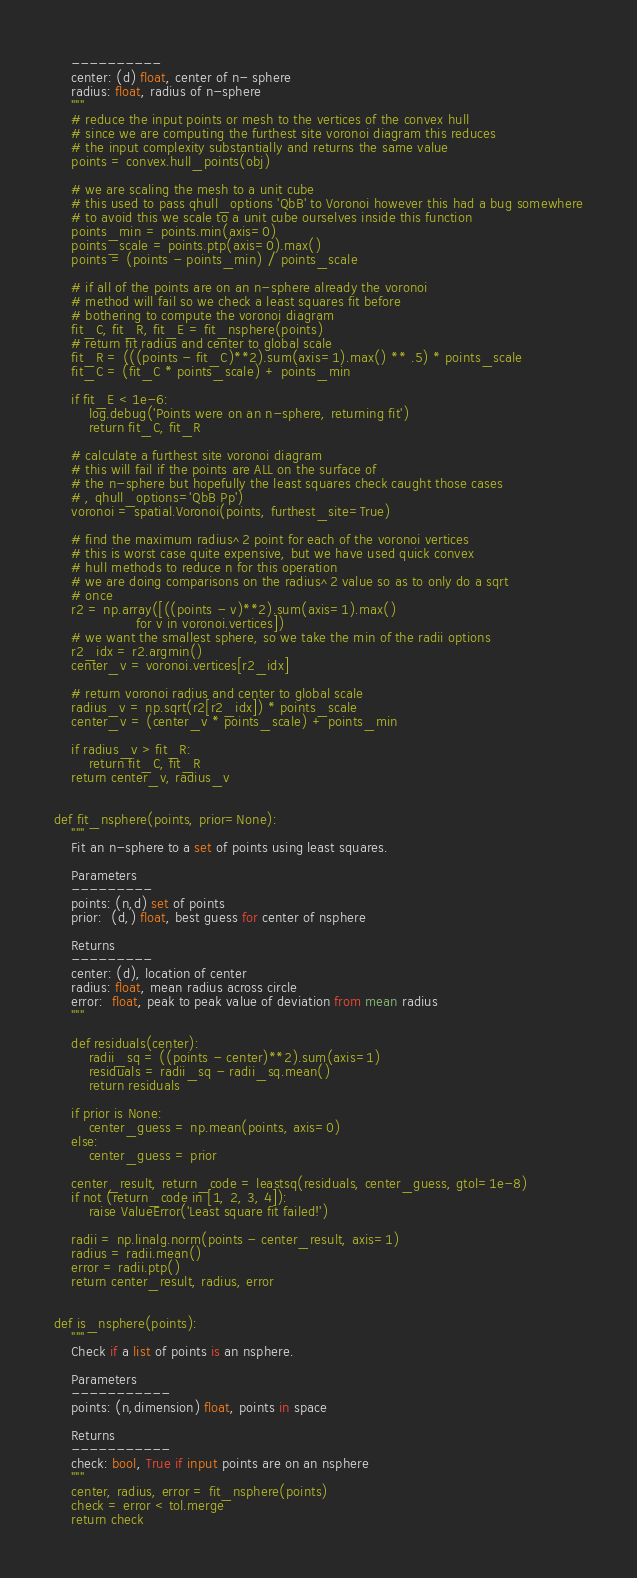<code> <loc_0><loc_0><loc_500><loc_500><_Python_>    ----------
    center: (d) float, center of n- sphere
    radius: float, radius of n-sphere
    """
    # reduce the input points or mesh to the vertices of the convex hull
    # since we are computing the furthest site voronoi diagram this reduces
    # the input complexity substantially and returns the same value
    points = convex.hull_points(obj)

    # we are scaling the mesh to a unit cube
    # this used to pass qhull_options 'QbB' to Voronoi however this had a bug somewhere
    # to avoid this we scale to a unit cube ourselves inside this function
    points_min = points.min(axis=0)
    points_scale = points.ptp(axis=0).max()
    points = (points - points_min) / points_scale

    # if all of the points are on an n-sphere already the voronoi
    # method will fail so we check a least squares fit before
    # bothering to compute the voronoi diagram
    fit_C, fit_R, fit_E = fit_nsphere(points)
    # return fit radius and center to global scale
    fit_R = (((points - fit_C)**2).sum(axis=1).max() ** .5) * points_scale
    fit_C = (fit_C * points_scale) + points_min

    if fit_E < 1e-6:
        log.debug('Points were on an n-sphere, returning fit')
        return fit_C, fit_R

    # calculate a furthest site voronoi diagram
    # this will fail if the points are ALL on the surface of
    # the n-sphere but hopefully the least squares check caught those cases
    # , qhull_options='QbB Pp')
    voronoi = spatial.Voronoi(points, furthest_site=True)

    # find the maximum radius^2 point for each of the voronoi vertices
    # this is worst case quite expensive, but we have used quick convex
    # hull methods to reduce n for this operation
    # we are doing comparisons on the radius^2 value so as to only do a sqrt
    # once
    r2 = np.array([((points - v)**2).sum(axis=1).max()
                   for v in voronoi.vertices])
    # we want the smallest sphere, so we take the min of the radii options
    r2_idx = r2.argmin()
    center_v = voronoi.vertices[r2_idx]

    # return voronoi radius and center to global scale
    radius_v = np.sqrt(r2[r2_idx]) * points_scale
    center_v = (center_v * points_scale) + points_min

    if radius_v > fit_R:
        return fit_C, fit_R
    return center_v, radius_v


def fit_nsphere(points, prior=None):
    """
    Fit an n-sphere to a set of points using least squares.

    Parameters
    ---------
    points: (n,d) set of points
    prior:  (d,) float, best guess for center of nsphere

    Returns
    ---------
    center: (d), location of center
    radius: float, mean radius across circle
    error:  float, peak to peak value of deviation from mean radius
    """

    def residuals(center):
        radii_sq = ((points - center)**2).sum(axis=1)
        residuals = radii_sq - radii_sq.mean()
        return residuals

    if prior is None:
        center_guess = np.mean(points, axis=0)
    else:
        center_guess = prior

    center_result, return_code = leastsq(residuals, center_guess, gtol=1e-8)
    if not (return_code in [1, 2, 3, 4]):
        raise ValueError('Least square fit failed!')

    radii = np.linalg.norm(points - center_result, axis=1)
    radius = radii.mean()
    error = radii.ptp()
    return center_result, radius, error


def is_nsphere(points):
    """
    Check if a list of points is an nsphere.

    Parameters
    -----------
    points: (n,dimension) float, points in space

    Returns
    -----------
    check: bool, True if input points are on an nsphere
    """
    center, radius, error = fit_nsphere(points)
    check = error < tol.merge
    return check
</code> 